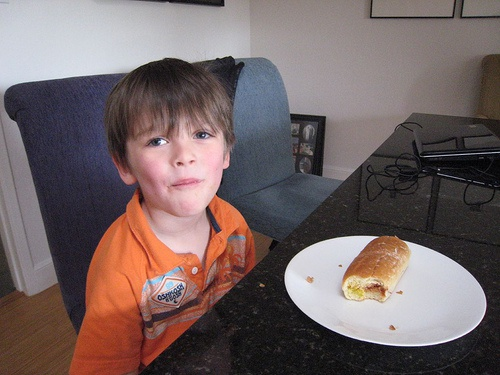Describe the objects in this image and their specific colors. I can see dining table in darkgray, black, lightgray, and gray tones, people in darkgray, brown, lightpink, black, and gray tones, chair in darkgray, black, and purple tones, chair in darkgray, gray, and black tones, and sandwich in darkgray, brown, and tan tones in this image. 